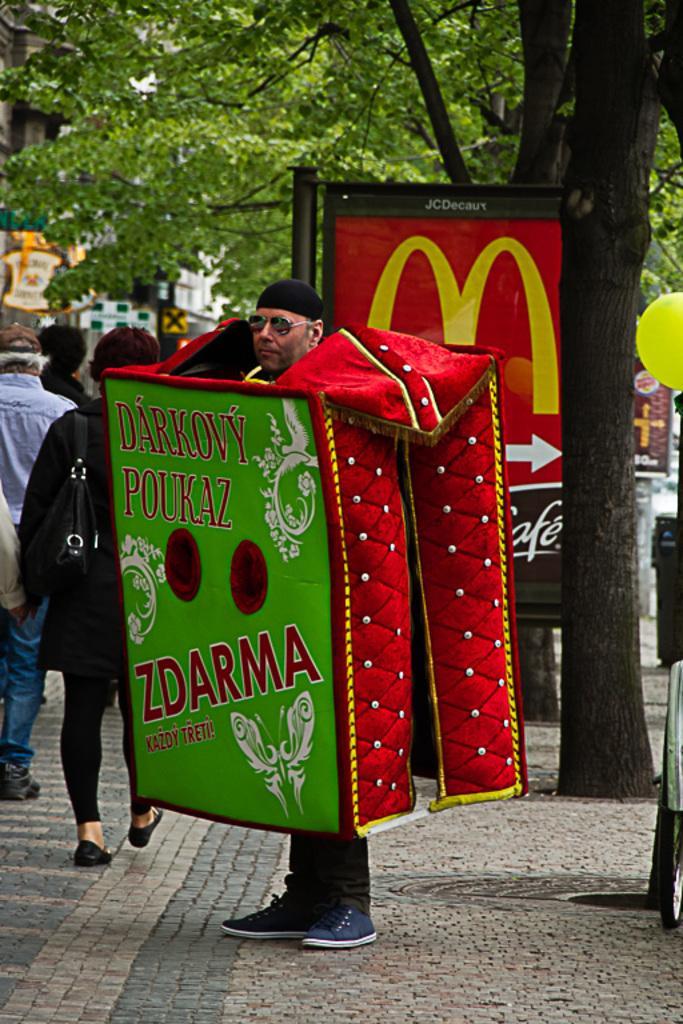Describe this image in one or two sentences. In this picture we can see a person standing on the ground, he is wearing a costume, goggles and in the background we can see trees, balloon, banners, people and some objects. 